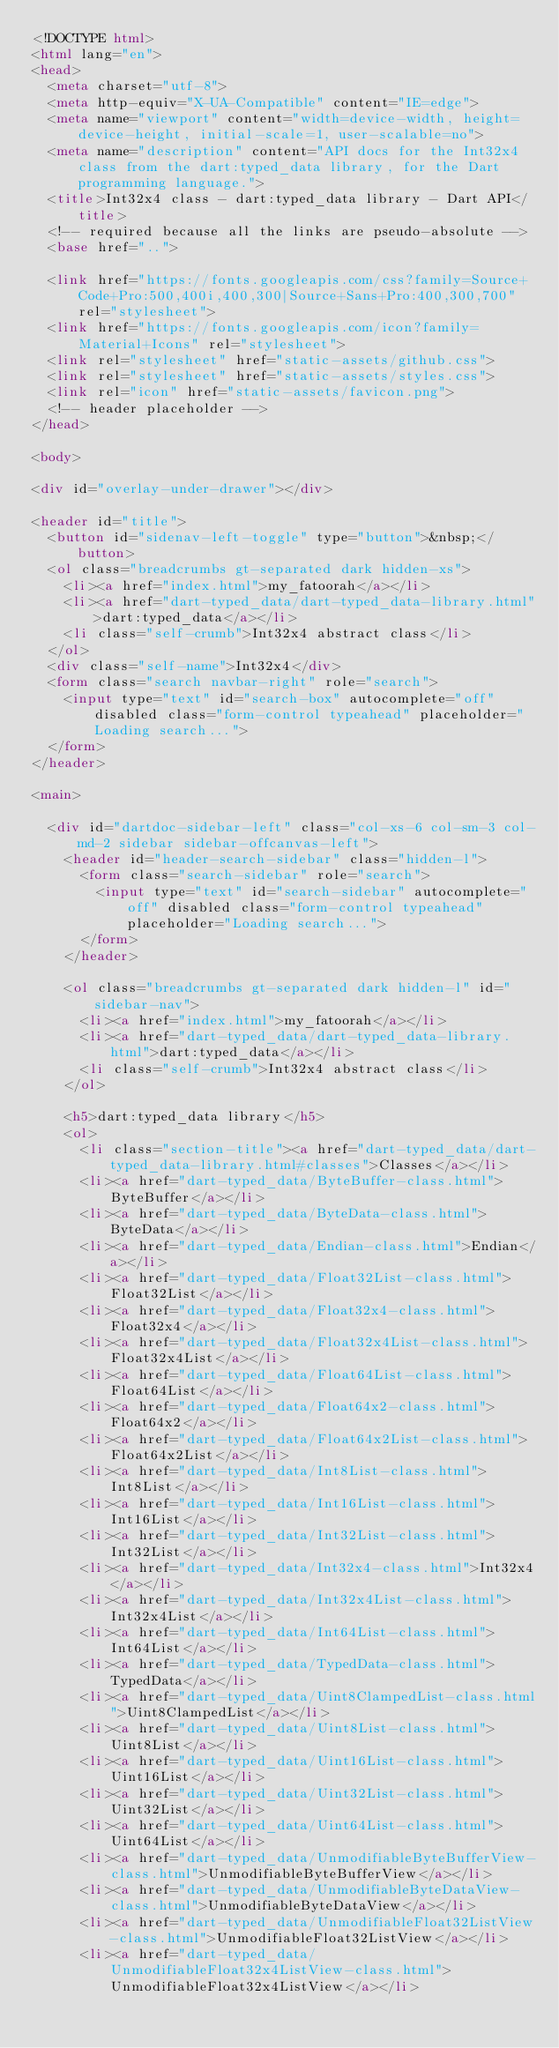<code> <loc_0><loc_0><loc_500><loc_500><_HTML_><!DOCTYPE html>
<html lang="en">
<head>
  <meta charset="utf-8">
  <meta http-equiv="X-UA-Compatible" content="IE=edge">
  <meta name="viewport" content="width=device-width, height=device-height, initial-scale=1, user-scalable=no">
  <meta name="description" content="API docs for the Int32x4 class from the dart:typed_data library, for the Dart programming language.">
  <title>Int32x4 class - dart:typed_data library - Dart API</title>
  <!-- required because all the links are pseudo-absolute -->
  <base href="..">

  <link href="https://fonts.googleapis.com/css?family=Source+Code+Pro:500,400i,400,300|Source+Sans+Pro:400,300,700" rel="stylesheet">
  <link href="https://fonts.googleapis.com/icon?family=Material+Icons" rel="stylesheet">
  <link rel="stylesheet" href="static-assets/github.css">
  <link rel="stylesheet" href="static-assets/styles.css">
  <link rel="icon" href="static-assets/favicon.png">
  <!-- header placeholder -->
</head>

<body>

<div id="overlay-under-drawer"></div>

<header id="title">
  <button id="sidenav-left-toggle" type="button">&nbsp;</button>
  <ol class="breadcrumbs gt-separated dark hidden-xs">
    <li><a href="index.html">my_fatoorah</a></li>
    <li><a href="dart-typed_data/dart-typed_data-library.html">dart:typed_data</a></li>
    <li class="self-crumb">Int32x4 abstract class</li>
  </ol>
  <div class="self-name">Int32x4</div>
  <form class="search navbar-right" role="search">
    <input type="text" id="search-box" autocomplete="off" disabled class="form-control typeahead" placeholder="Loading search...">
  </form>
</header>

<main>

  <div id="dartdoc-sidebar-left" class="col-xs-6 col-sm-3 col-md-2 sidebar sidebar-offcanvas-left">
    <header id="header-search-sidebar" class="hidden-l">
      <form class="search-sidebar" role="search">
        <input type="text" id="search-sidebar" autocomplete="off" disabled class="form-control typeahead" placeholder="Loading search...">
      </form>
    </header>
    
    <ol class="breadcrumbs gt-separated dark hidden-l" id="sidebar-nav">
      <li><a href="index.html">my_fatoorah</a></li>
      <li><a href="dart-typed_data/dart-typed_data-library.html">dart:typed_data</a></li>
      <li class="self-crumb">Int32x4 abstract class</li>
    </ol>
    
    <h5>dart:typed_data library</h5>
    <ol>
      <li class="section-title"><a href="dart-typed_data/dart-typed_data-library.html#classes">Classes</a></li>
      <li><a href="dart-typed_data/ByteBuffer-class.html">ByteBuffer</a></li>
      <li><a href="dart-typed_data/ByteData-class.html">ByteData</a></li>
      <li><a href="dart-typed_data/Endian-class.html">Endian</a></li>
      <li><a href="dart-typed_data/Float32List-class.html">Float32List</a></li>
      <li><a href="dart-typed_data/Float32x4-class.html">Float32x4</a></li>
      <li><a href="dart-typed_data/Float32x4List-class.html">Float32x4List</a></li>
      <li><a href="dart-typed_data/Float64List-class.html">Float64List</a></li>
      <li><a href="dart-typed_data/Float64x2-class.html">Float64x2</a></li>
      <li><a href="dart-typed_data/Float64x2List-class.html">Float64x2List</a></li>
      <li><a href="dart-typed_data/Int8List-class.html">Int8List</a></li>
      <li><a href="dart-typed_data/Int16List-class.html">Int16List</a></li>
      <li><a href="dart-typed_data/Int32List-class.html">Int32List</a></li>
      <li><a href="dart-typed_data/Int32x4-class.html">Int32x4</a></li>
      <li><a href="dart-typed_data/Int32x4List-class.html">Int32x4List</a></li>
      <li><a href="dart-typed_data/Int64List-class.html">Int64List</a></li>
      <li><a href="dart-typed_data/TypedData-class.html">TypedData</a></li>
      <li><a href="dart-typed_data/Uint8ClampedList-class.html">Uint8ClampedList</a></li>
      <li><a href="dart-typed_data/Uint8List-class.html">Uint8List</a></li>
      <li><a href="dart-typed_data/Uint16List-class.html">Uint16List</a></li>
      <li><a href="dart-typed_data/Uint32List-class.html">Uint32List</a></li>
      <li><a href="dart-typed_data/Uint64List-class.html">Uint64List</a></li>
      <li><a href="dart-typed_data/UnmodifiableByteBufferView-class.html">UnmodifiableByteBufferView</a></li>
      <li><a href="dart-typed_data/UnmodifiableByteDataView-class.html">UnmodifiableByteDataView</a></li>
      <li><a href="dart-typed_data/UnmodifiableFloat32ListView-class.html">UnmodifiableFloat32ListView</a></li>
      <li><a href="dart-typed_data/UnmodifiableFloat32x4ListView-class.html">UnmodifiableFloat32x4ListView</a></li></code> 